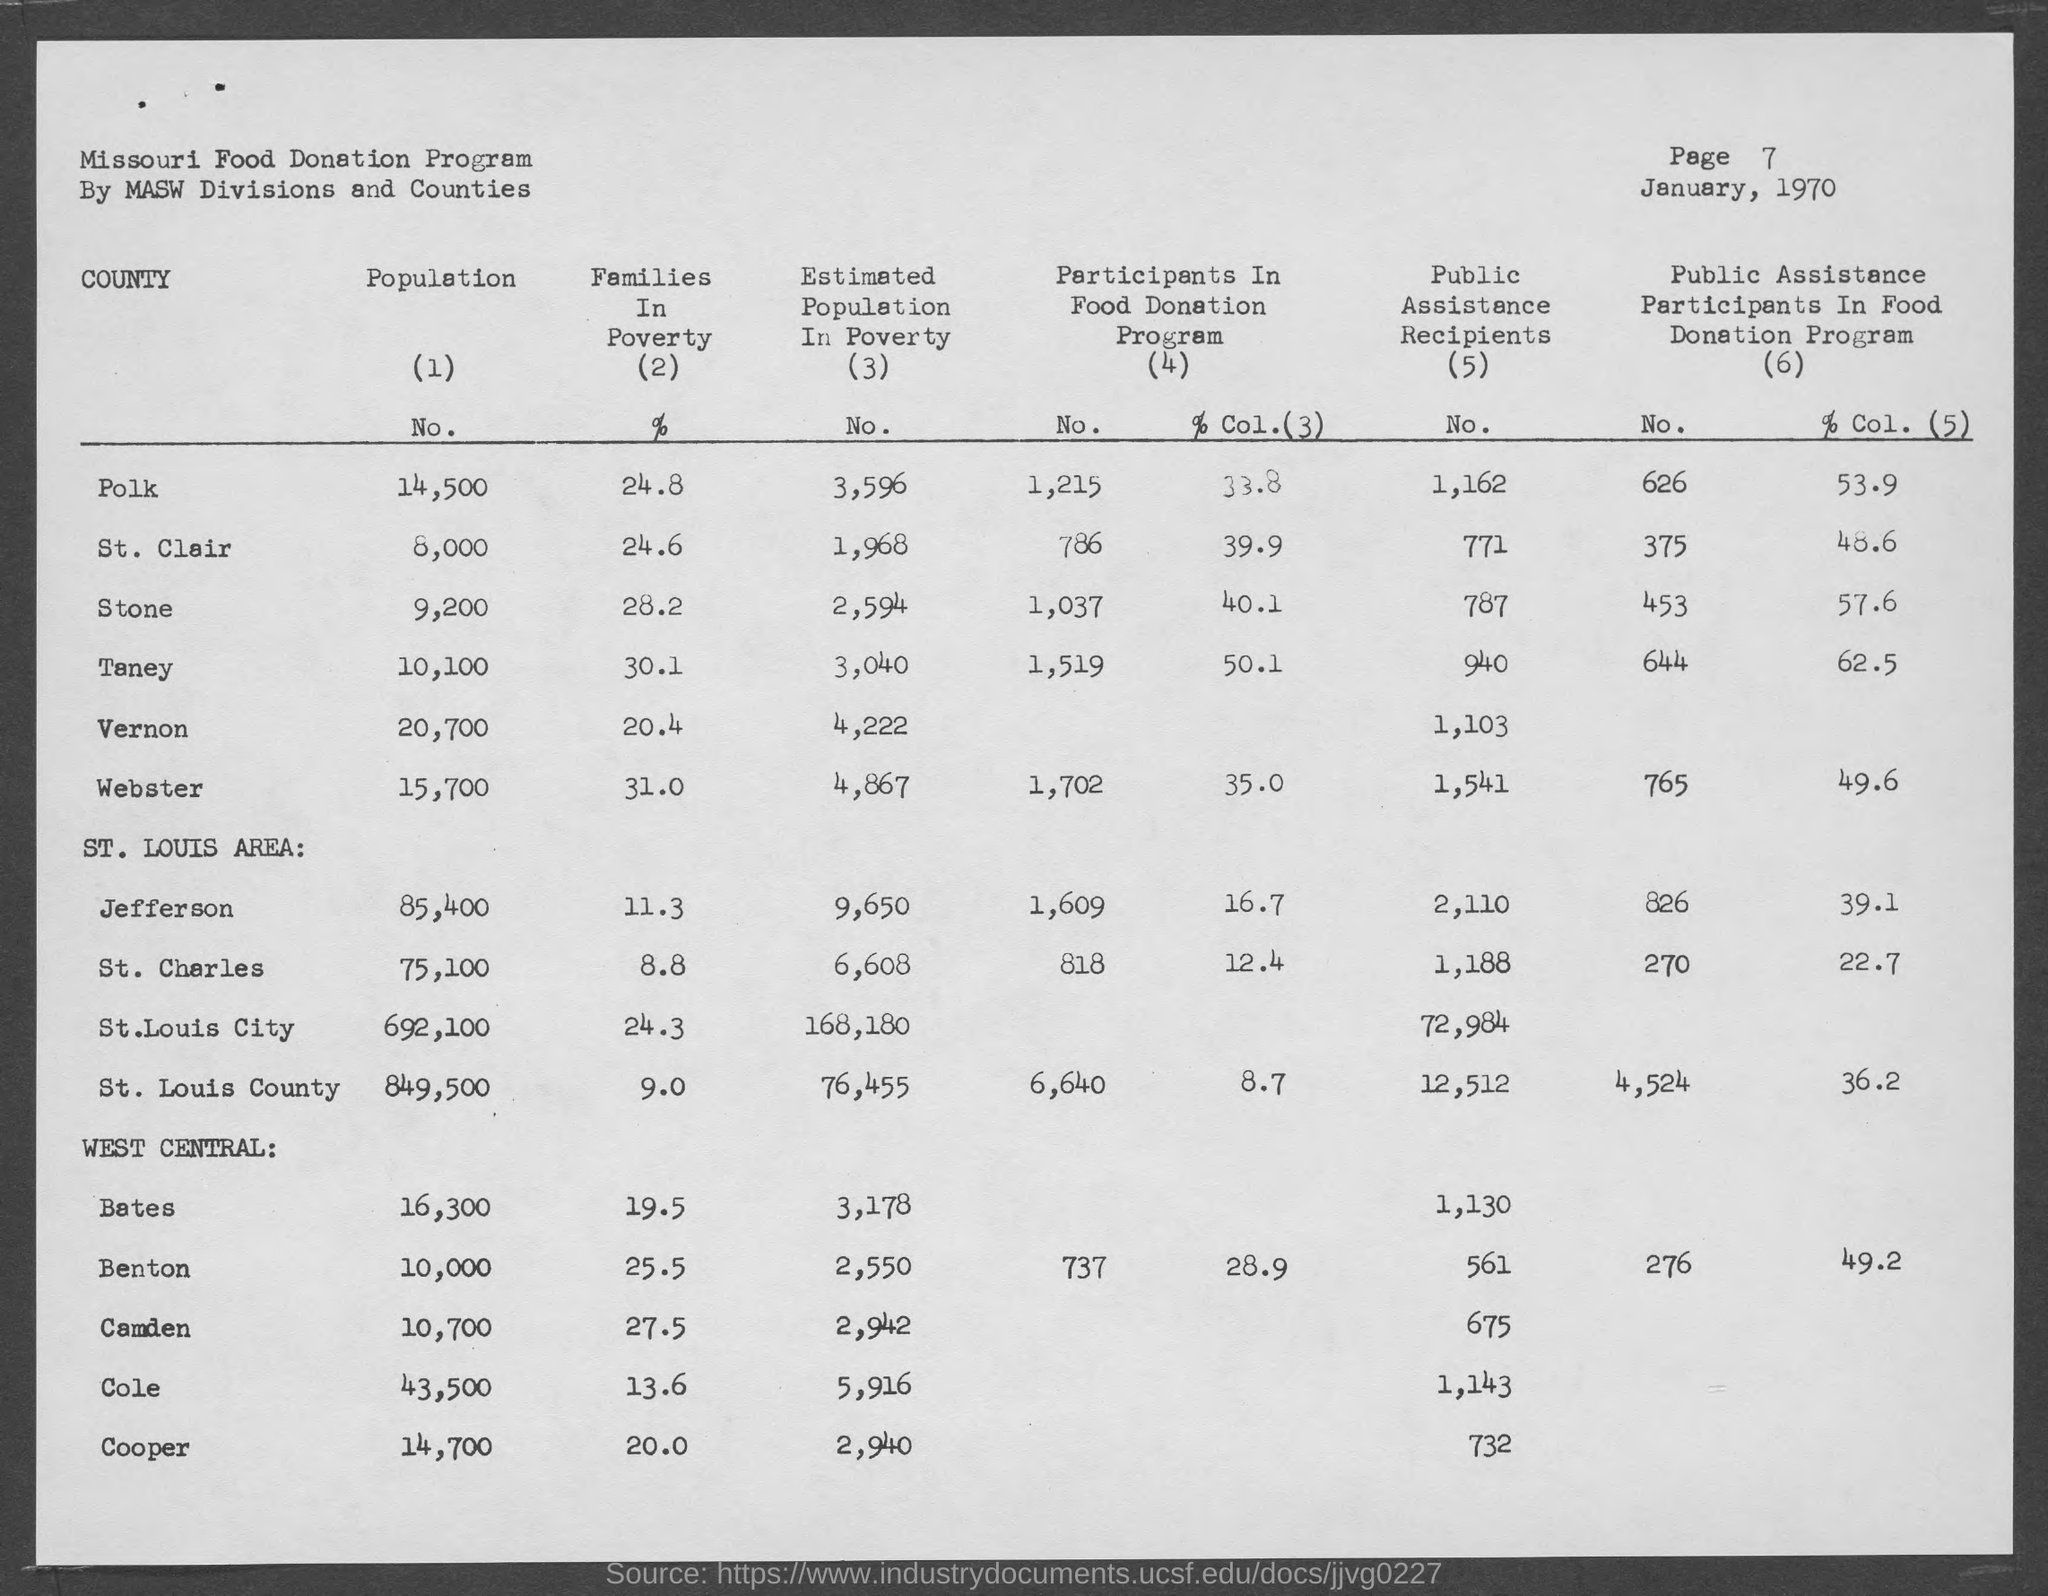What is the page number at top of the page?
Offer a terse response. 7. What is the population in polk county?
Make the answer very short. 14,500. What is the population in st. clair county?
Provide a succinct answer. 8,000. What is the population in stone county?
Your answer should be compact. 9,200. What is the population in taney county ?
Your answer should be compact. 10,100. What is the population in vernon county ?
Your answer should be very brief. 20,700. What is the population in webster county?
Your response must be concise. 15,700. What is the population in bates county ?
Offer a very short reply. 16300. What is the population in benton county ?
Your answer should be very brief. 10,000. What is the population in cole county?
Offer a very short reply. 43,500. 